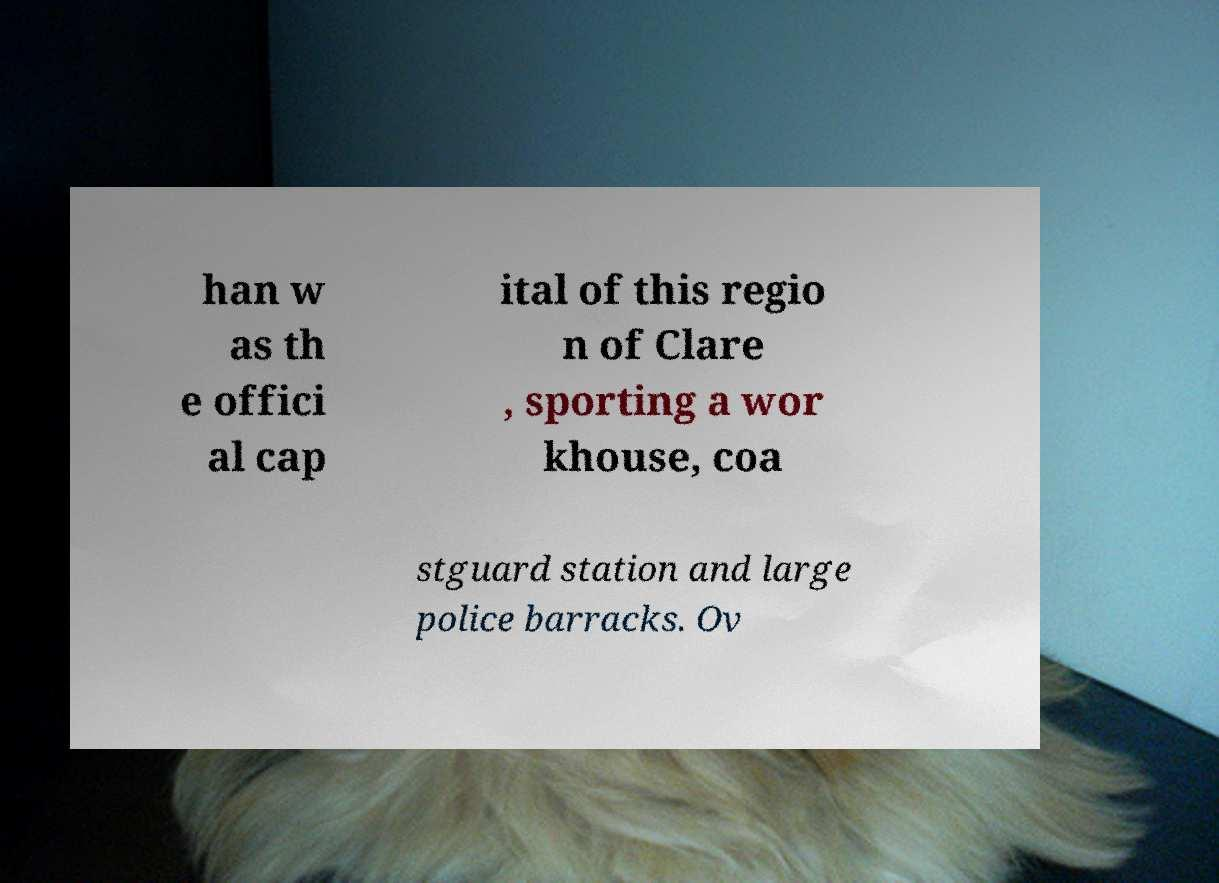There's text embedded in this image that I need extracted. Can you transcribe it verbatim? han w as th e offici al cap ital of this regio n of Clare , sporting a wor khouse, coa stguard station and large police barracks. Ov 